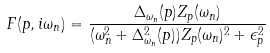Convert formula to latex. <formula><loc_0><loc_0><loc_500><loc_500>F ( p , i \omega _ { n } ) = \frac { \Delta _ { \omega _ { n } } ( p ) Z _ { p } ( \omega _ { n } ) } { ( \omega _ { n } ^ { 2 } + \Delta ^ { 2 } _ { \omega _ { n } } ( p ) ) Z _ { p } ( \omega _ { n } ) ^ { 2 } + \epsilon _ { p } ^ { 2 } }</formula> 